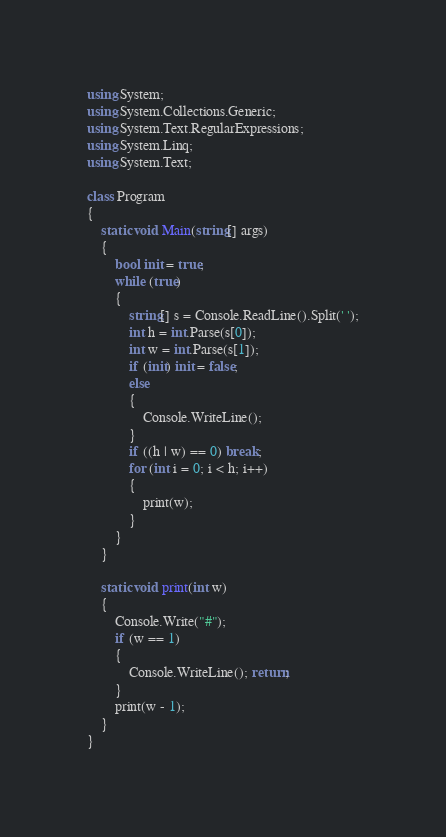<code> <loc_0><loc_0><loc_500><loc_500><_C#_>using System;
using System.Collections.Generic;
using System.Text.RegularExpressions;
using System.Linq;
using System.Text;

class Program
{
    static void Main(string[] args)
    {
        bool init = true;
        while (true)
        {
            string[] s = Console.ReadLine().Split(' ');
            int h = int.Parse(s[0]);
            int w = int.Parse(s[1]);
            if (init) init = false;
            else
            {
                Console.WriteLine();
            }
            if ((h | w) == 0) break;
            for (int i = 0; i < h; i++)
            {
                print(w);
            }
        }
    }

    static void print(int w)
    {
        Console.Write("#");
        if (w == 1)
        {
            Console.WriteLine(); return;
        }
        print(w - 1);
    }
}</code> 